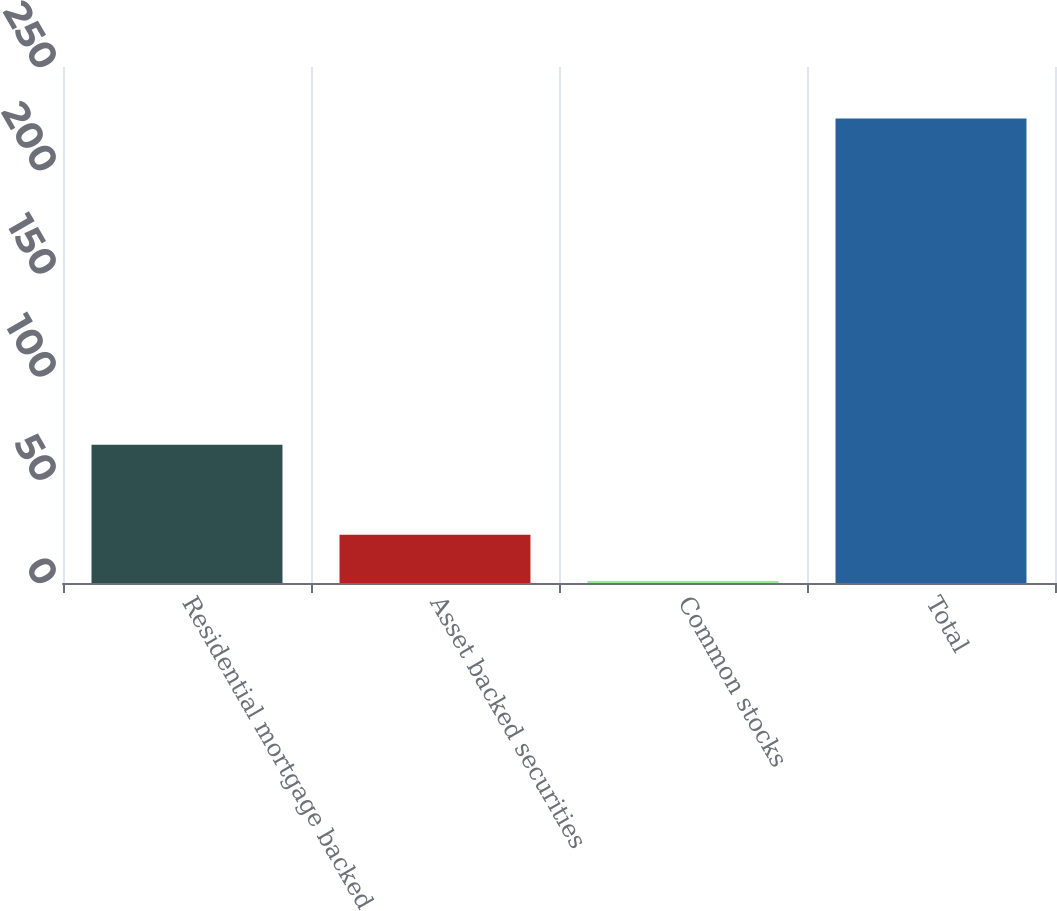Convert chart to OTSL. <chart><loc_0><loc_0><loc_500><loc_500><bar_chart><fcel>Residential mortgage backed<fcel>Asset backed securities<fcel>Common stocks<fcel>Total<nl><fcel>67<fcel>23.4<fcel>1<fcel>225<nl></chart> 